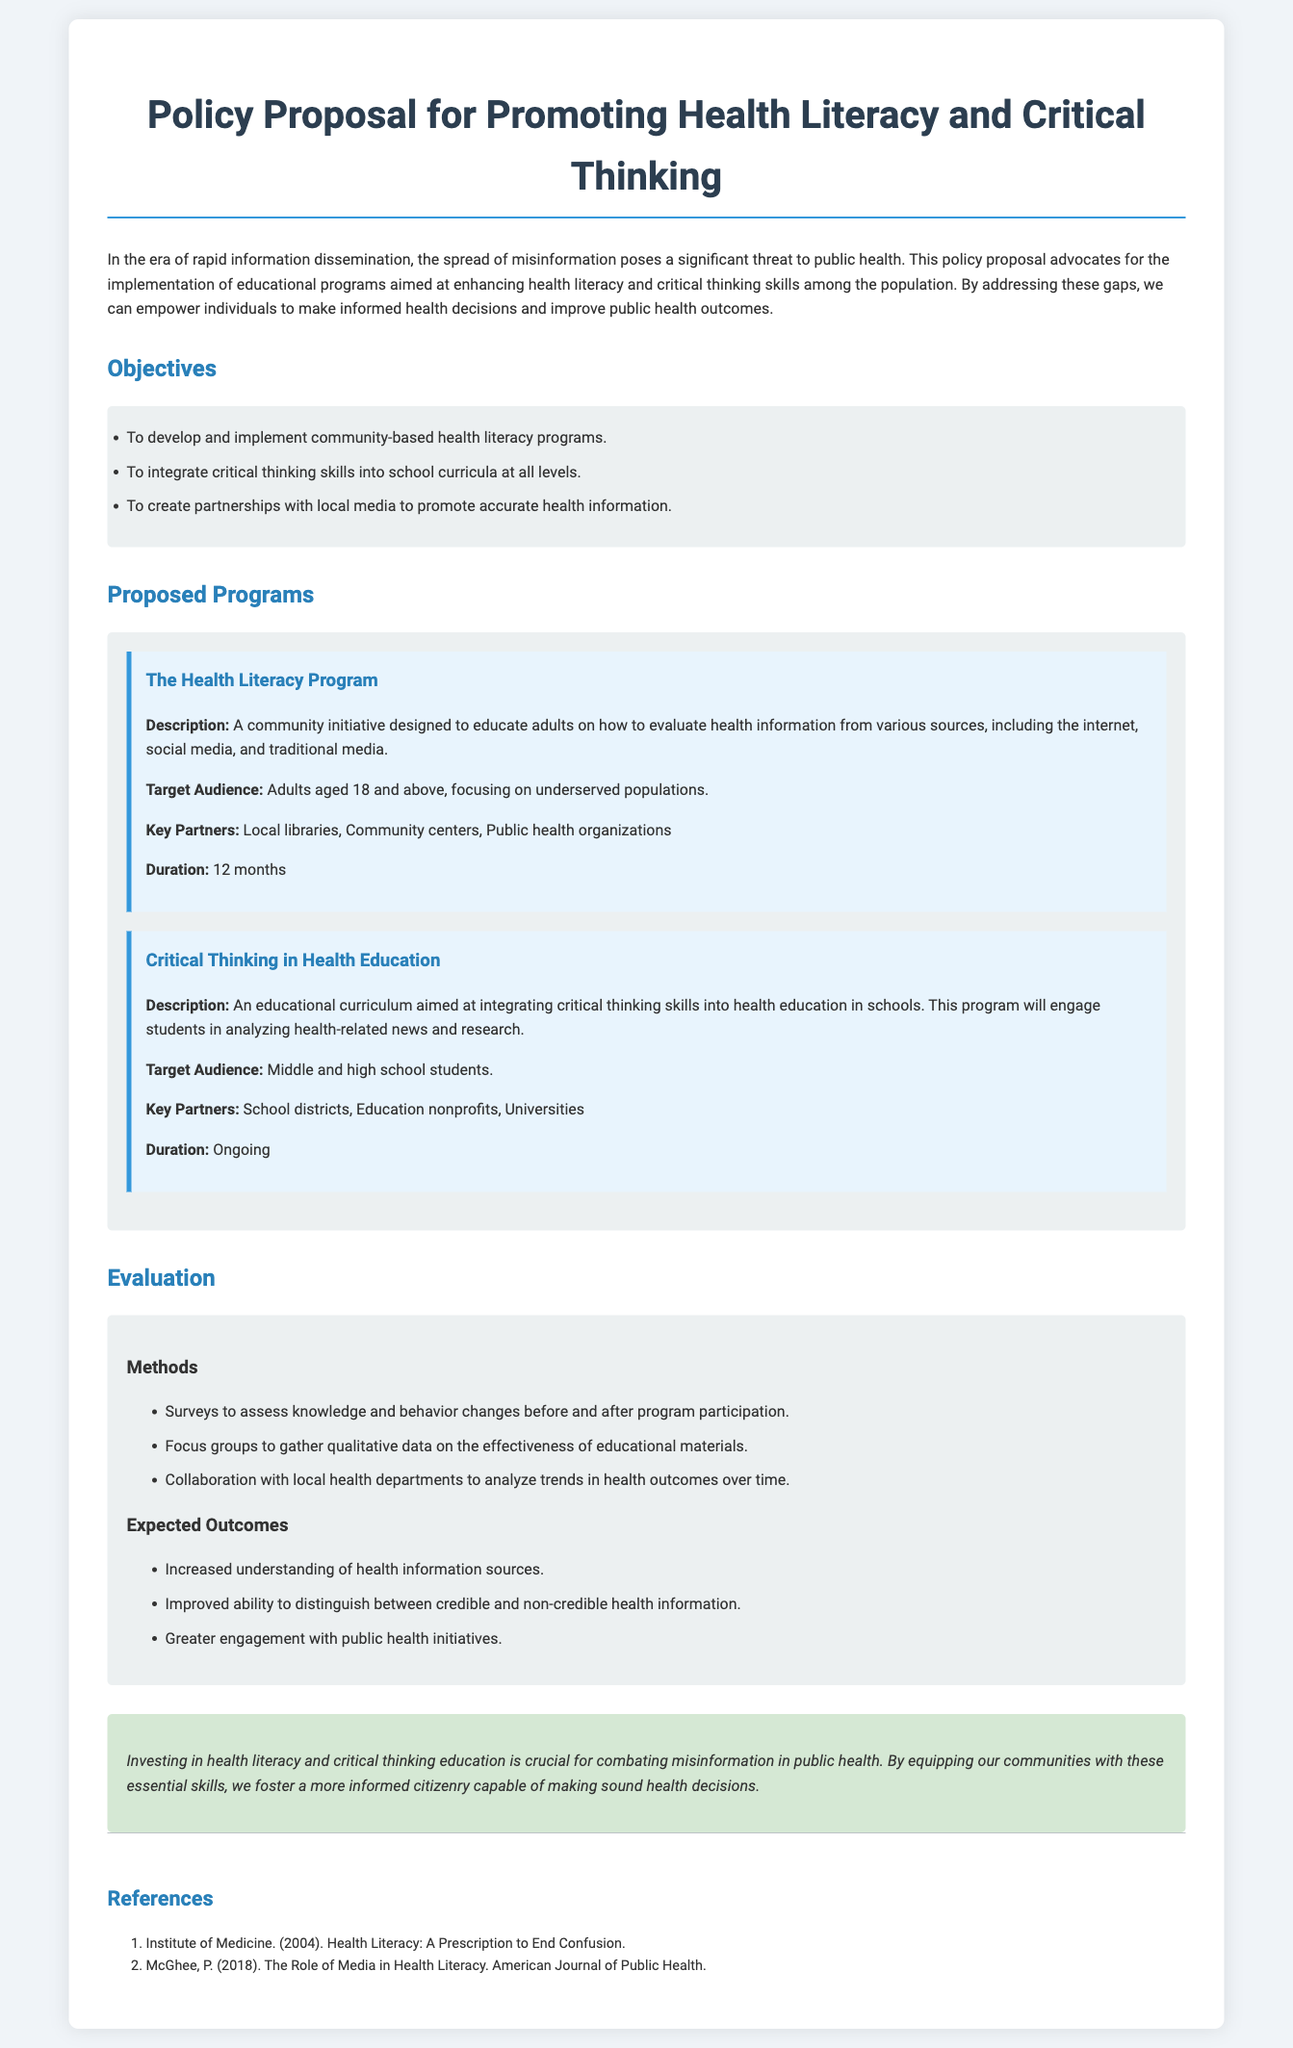What is the title of the document? The title of the document is explicitly stated at the beginning.
Answer: Policy Proposal for Promoting Health Literacy and Critical Thinking What is the duration of The Health Literacy Program? The document lists specific durations for various programs under the Proposed Programs section.
Answer: 12 months Who is the target audience for the Critical Thinking in Health Education program? The document identifies specific target audiences for each proposed program.
Answer: Middle and high school students What is one method of evaluation mentioned in the document? The evaluation section lists various methods used to assess the effectiveness of programs.
Answer: Surveys Name one of the key partners for The Health Literacy Program. The document outlines partnerships for the proposed programs.
Answer: Local libraries How many objectives are listed in the document? The objectives section presents specific goals set for the policy proposal.
Answer: Three What is one expected outcome of the educational programs? The expected outcomes are summarized in a list that highlights what the programs aim to achieve.
Answer: Increased understanding of health information sources What type of organizations are suggested as key partners for the health literacy programs? The document categorizes potential partnerships that would support its objectives.
Answer: Public health organizations 